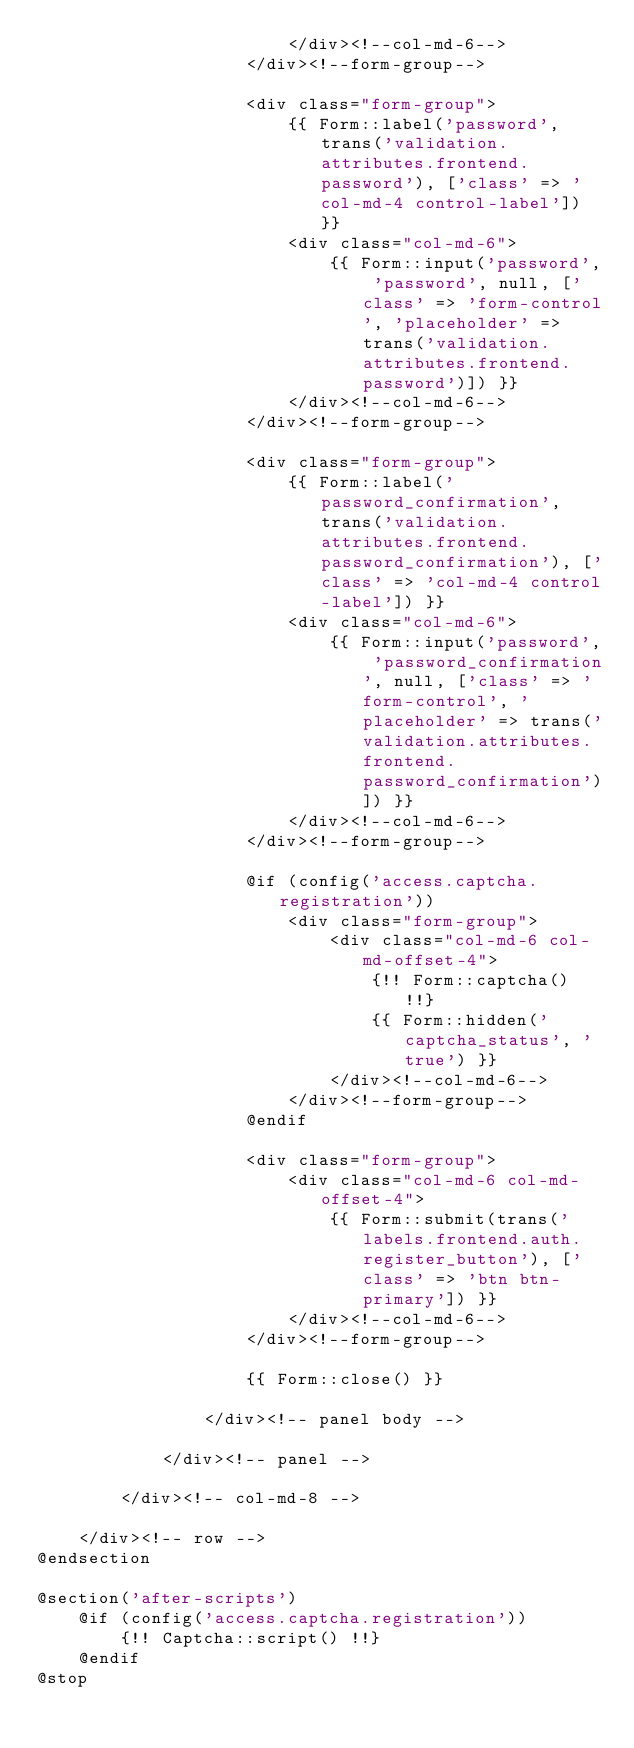Convert code to text. <code><loc_0><loc_0><loc_500><loc_500><_PHP_>                        </div><!--col-md-6-->
                    </div><!--form-group-->

                    <div class="form-group">
                        {{ Form::label('password', trans('validation.attributes.frontend.password'), ['class' => 'col-md-4 control-label']) }}
                        <div class="col-md-6">
                            {{ Form::input('password', 'password', null, ['class' => 'form-control', 'placeholder' => trans('validation.attributes.frontend.password')]) }}
                        </div><!--col-md-6-->
                    </div><!--form-group-->

                    <div class="form-group">
                        {{ Form::label('password_confirmation', trans('validation.attributes.frontend.password_confirmation'), ['class' => 'col-md-4 control-label']) }}
                        <div class="col-md-6">
                            {{ Form::input('password', 'password_confirmation', null, ['class' => 'form-control', 'placeholder' => trans('validation.attributes.frontend.password_confirmation')]) }}
                        </div><!--col-md-6-->
                    </div><!--form-group-->

                    @if (config('access.captcha.registration'))
                        <div class="form-group">
                            <div class="col-md-6 col-md-offset-4">
                                {!! Form::captcha() !!}
                                {{ Form::hidden('captcha_status', 'true') }}
                            </div><!--col-md-6-->
                        </div><!--form-group-->
                    @endif

                    <div class="form-group">
                        <div class="col-md-6 col-md-offset-4">
                            {{ Form::submit(trans('labels.frontend.auth.register_button'), ['class' => 'btn btn-primary']) }}
                        </div><!--col-md-6-->
                    </div><!--form-group-->

                    {{ Form::close() }}

                </div><!-- panel body -->

            </div><!-- panel -->

        </div><!-- col-md-8 -->

    </div><!-- row -->
@endsection

@section('after-scripts')
    @if (config('access.captcha.registration'))
        {!! Captcha::script() !!}
    @endif
@stop</code> 